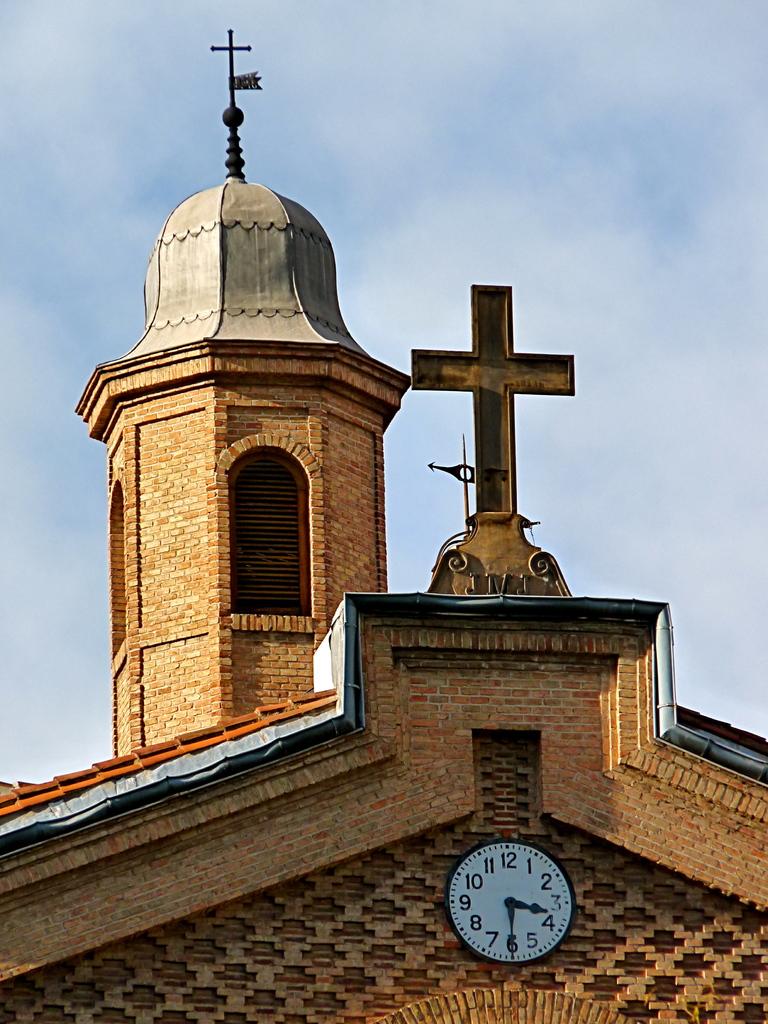What time is on the clock?
Your response must be concise. 3:30. This is a church?
Give a very brief answer. Answering does not require reading text in the image. 